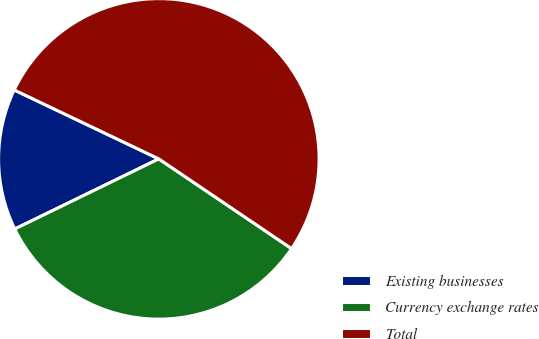<chart> <loc_0><loc_0><loc_500><loc_500><pie_chart><fcel>Existing businesses<fcel>Currency exchange rates<fcel>Total<nl><fcel>14.29%<fcel>33.33%<fcel>52.38%<nl></chart> 